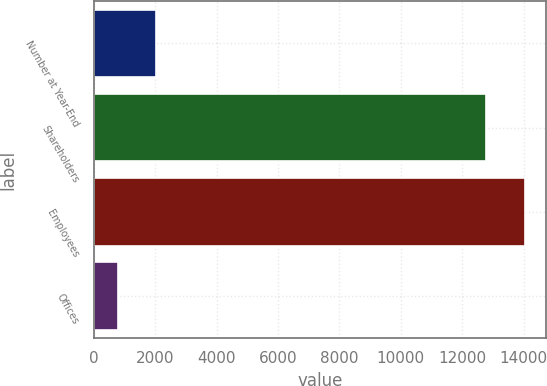<chart> <loc_0><loc_0><loc_500><loc_500><bar_chart><fcel>Number at Year-End<fcel>Shareholders<fcel>Employees<fcel>Offices<nl><fcel>2036.7<fcel>12773<fcel>14031.7<fcel>778<nl></chart> 